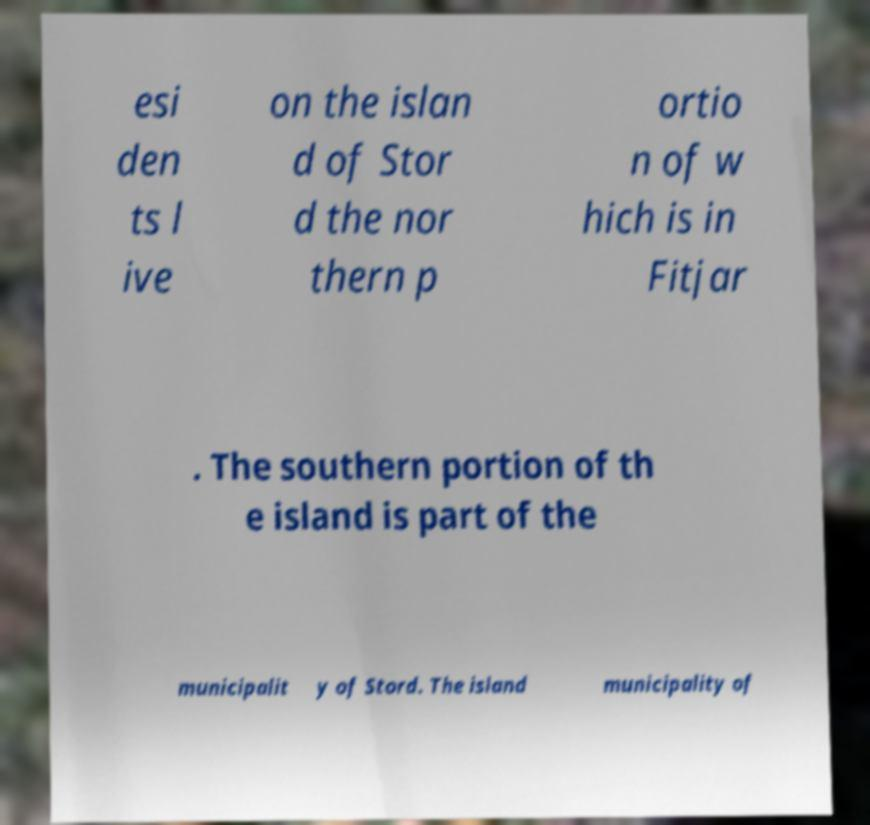Could you extract and type out the text from this image? esi den ts l ive on the islan d of Stor d the nor thern p ortio n of w hich is in Fitjar . The southern portion of th e island is part of the municipalit y of Stord. The island municipality of 